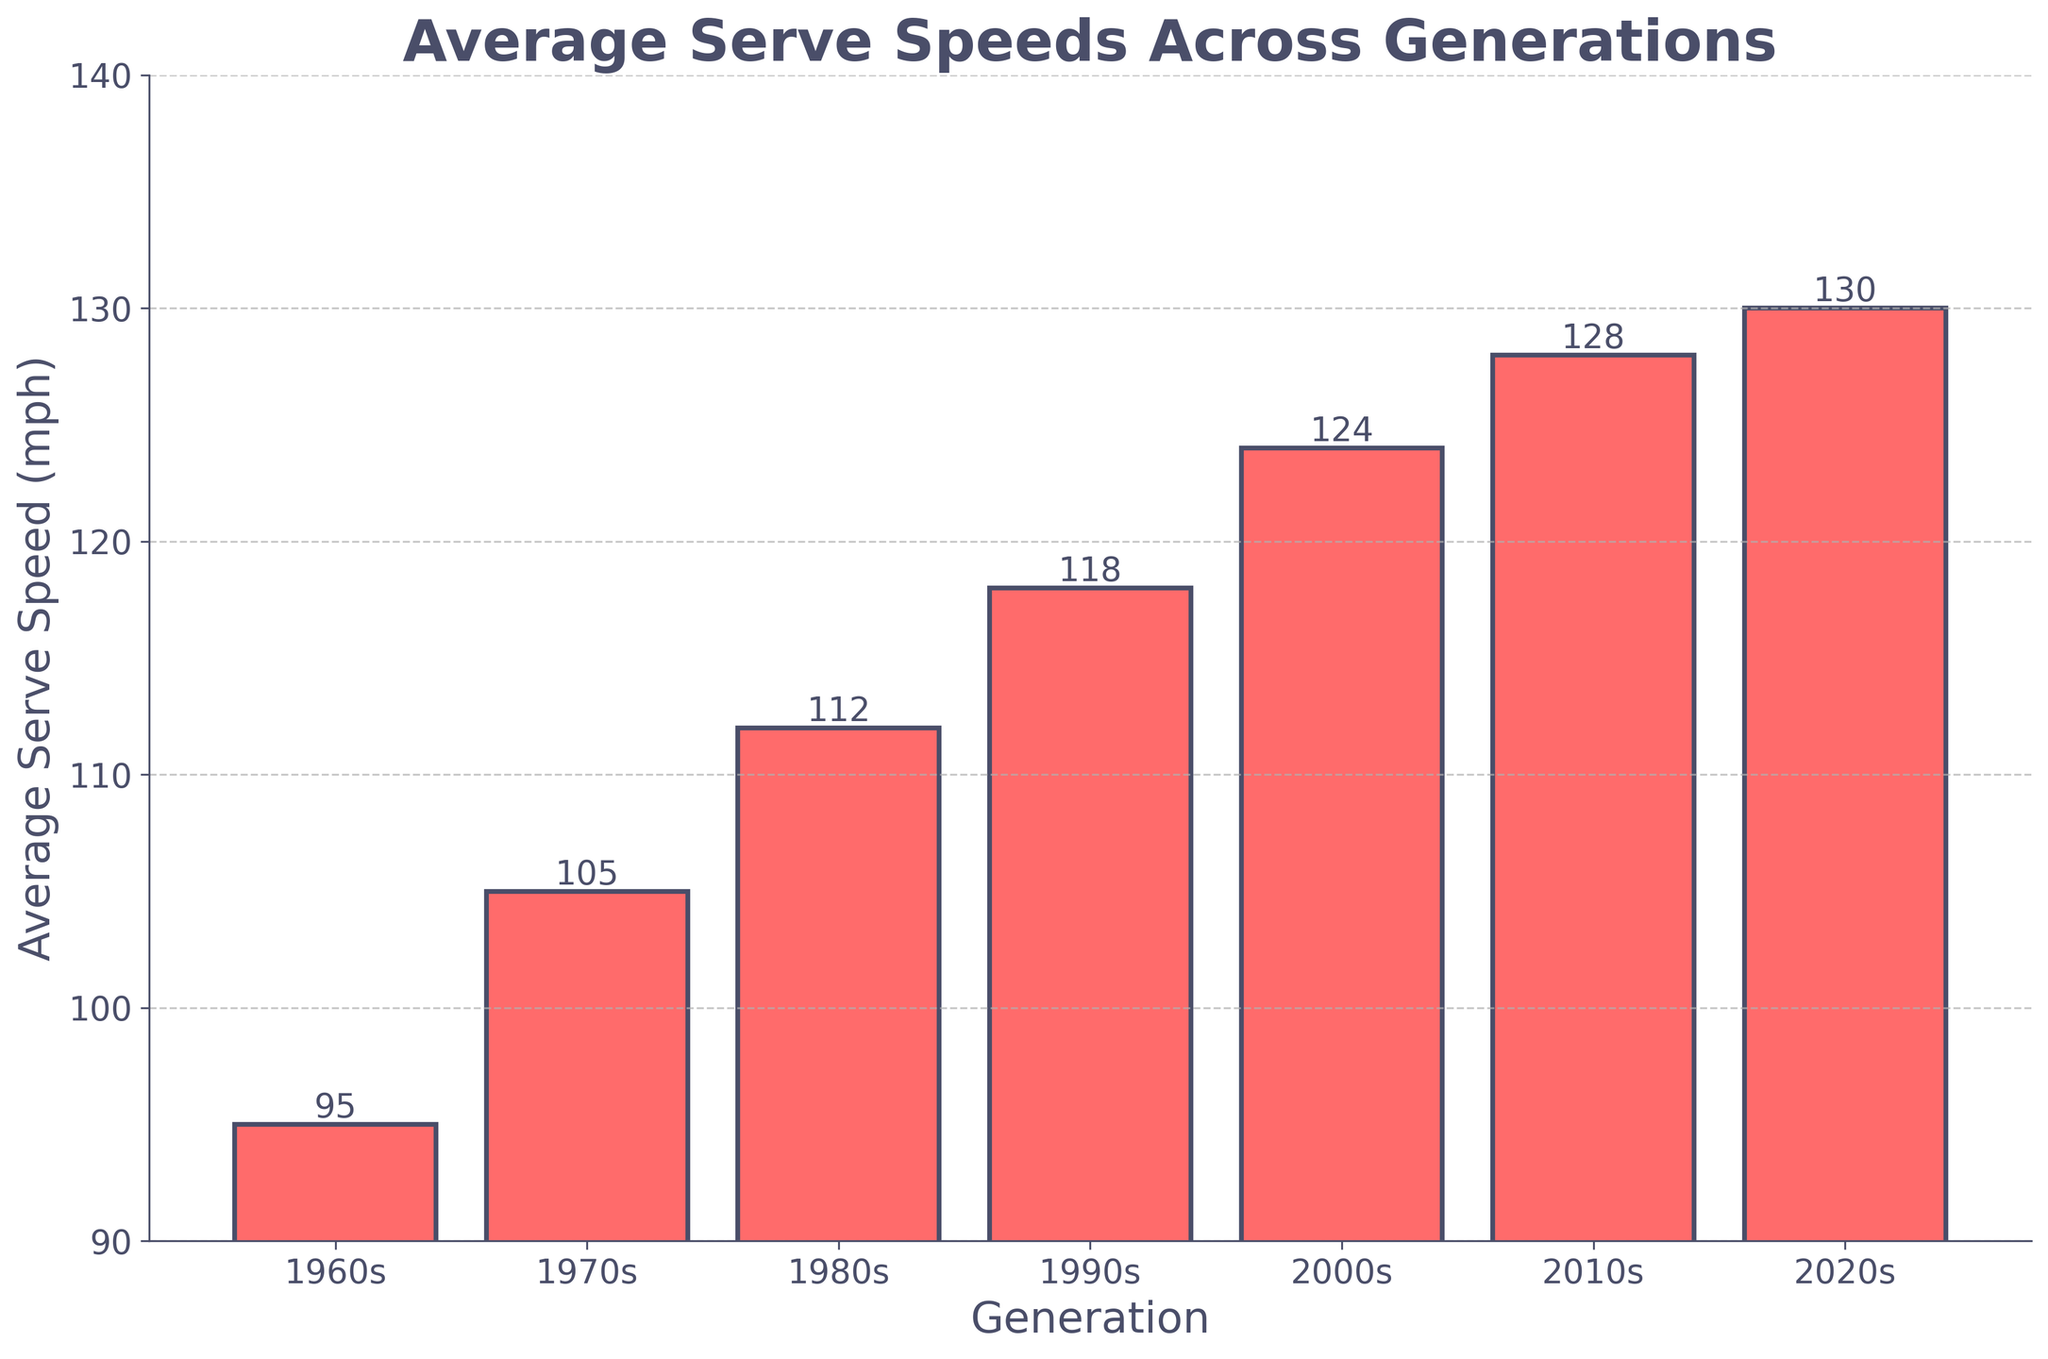What is the average serve speed in the 2010s generation? The bar for the 2010s generation indicates the average serve speed. The height of the bar shows the serve speed value.
Answer: 128 mph How much faster is the average serve speed in the 2020s compared to the 1970s? The bar for the 2020s shows an average serve speed of 130 mph, and the bar for the 1970s shows 105 mph. The difference is calculated as 130 - 105.
Answer: 25 mph Which generation has the lowest average serve speed? The bar with the shortest height represents the lowest average serve speed. The 1960s generation has the shortest bar at 95 mph.
Answer: 1960s How many generations have an average serve speed above 120 mph? Identify the bars exceeding the 120 mph mark. The 2000s, 2010s, and 2020s generations are above 120 mph.
Answer: 3 generations What is the sum of the average serve speeds in the 1980s and 1990s generations? The bar for the 1980s shows 112 mph and the bar for the 1990s shows 118 mph. Adding them together gives 112 + 118.
Answer: 230 mph Between the 1960s and the 2000s, which generation has a higher average serve speed, and by how much? Compare the bars for the 1960s (95 mph) and the 2000s (124 mph). Subtract the 1960s value from the 2000s value: 124 - 95.
Answer: 2000s, by 29 mph If the average serve speed trend continues, what might you expect the average serve speed to be in the 2030s? Observing the steady increase from generation to generation, especially between the 2010s (128 mph) and 2020s (130 mph), a similar trend suggests a modest increase. Estimating roughly 2-3 mph increase could be reasonable.
Answer: Around 132-133 mph What is the total average serve speed across all generations shown? Sum the values for all generations: 95 (1960s) + 105 (1970s) + 112 (1980s) + 118 (1990s) + 124 (2000s) + 128 (2010s) + 130 (2020s). Add them together: 95 + 105 + 112 + 118 + 124 + 128 + 130.
Answer: 812 mph Which generation shows the largest increase in average serve speed compared to the previous generation? Calculate the differences between consecutive generations: 1970s-1960s (105-95) = 10, 1980s-1970s (112-105) = 7, 1990s-1980s (118-112) = 6, 2000s-1990s (124-118) = 6, 2010s-2000s (128-124) = 4, 2020s-2010s (130-128) = 2. The largest increase is between the 1960s and 1970s.
Answer: 1970s, 10 mph 